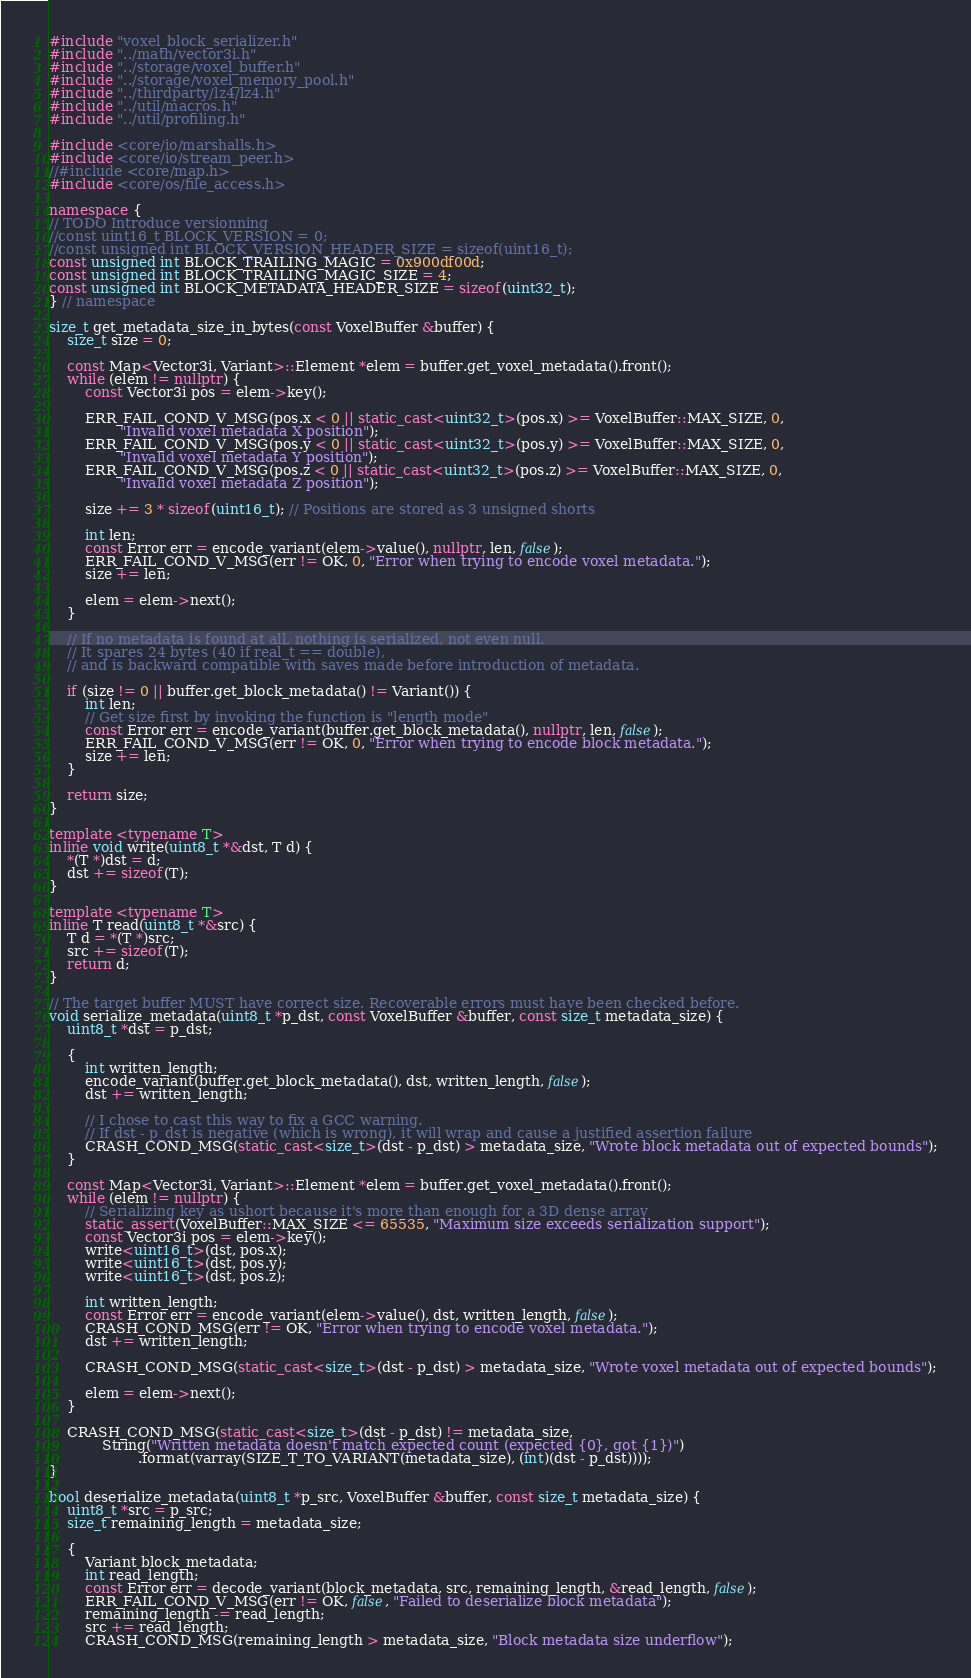<code> <loc_0><loc_0><loc_500><loc_500><_C++_>#include "voxel_block_serializer.h"
#include "../math/vector3i.h"
#include "../storage/voxel_buffer.h"
#include "../storage/voxel_memory_pool.h"
#include "../thirdparty/lz4/lz4.h"
#include "../util/macros.h"
#include "../util/profiling.h"

#include <core/io/marshalls.h>
#include <core/io/stream_peer.h>
//#include <core/map.h>
#include <core/os/file_access.h>

namespace {
// TODO Introduce versionning
//const uint16_t BLOCK_VERSION = 0;
//const unsigned int BLOCK_VERSION_HEADER_SIZE = sizeof(uint16_t);
const unsigned int BLOCK_TRAILING_MAGIC = 0x900df00d;
const unsigned int BLOCK_TRAILING_MAGIC_SIZE = 4;
const unsigned int BLOCK_METADATA_HEADER_SIZE = sizeof(uint32_t);
} // namespace

size_t get_metadata_size_in_bytes(const VoxelBuffer &buffer) {
	size_t size = 0;

	const Map<Vector3i, Variant>::Element *elem = buffer.get_voxel_metadata().front();
	while (elem != nullptr) {
		const Vector3i pos = elem->key();

		ERR_FAIL_COND_V_MSG(pos.x < 0 || static_cast<uint32_t>(pos.x) >= VoxelBuffer::MAX_SIZE, 0,
				"Invalid voxel metadata X position");
		ERR_FAIL_COND_V_MSG(pos.y < 0 || static_cast<uint32_t>(pos.y) >= VoxelBuffer::MAX_SIZE, 0,
				"Invalid voxel metadata Y position");
		ERR_FAIL_COND_V_MSG(pos.z < 0 || static_cast<uint32_t>(pos.z) >= VoxelBuffer::MAX_SIZE, 0,
				"Invalid voxel metadata Z position");

		size += 3 * sizeof(uint16_t); // Positions are stored as 3 unsigned shorts

		int len;
		const Error err = encode_variant(elem->value(), nullptr, len, false);
		ERR_FAIL_COND_V_MSG(err != OK, 0, "Error when trying to encode voxel metadata.");
		size += len;

		elem = elem->next();
	}

	// If no metadata is found at all, nothing is serialized, not even null.
	// It spares 24 bytes (40 if real_t == double),
	// and is backward compatible with saves made before introduction of metadata.

	if (size != 0 || buffer.get_block_metadata() != Variant()) {
		int len;
		// Get size first by invoking the function is "length mode"
		const Error err = encode_variant(buffer.get_block_metadata(), nullptr, len, false);
		ERR_FAIL_COND_V_MSG(err != OK, 0, "Error when trying to encode block metadata.");
		size += len;
	}

	return size;
}

template <typename T>
inline void write(uint8_t *&dst, T d) {
	*(T *)dst = d;
	dst += sizeof(T);
}

template <typename T>
inline T read(uint8_t *&src) {
	T d = *(T *)src;
	src += sizeof(T);
	return d;
}

// The target buffer MUST have correct size. Recoverable errors must have been checked before.
void serialize_metadata(uint8_t *p_dst, const VoxelBuffer &buffer, const size_t metadata_size) {
	uint8_t *dst = p_dst;

	{
		int written_length;
		encode_variant(buffer.get_block_metadata(), dst, written_length, false);
		dst += written_length;

		// I chose to cast this way to fix a GCC warning.
		// If dst - p_dst is negative (which is wrong), it will wrap and cause a justified assertion failure
		CRASH_COND_MSG(static_cast<size_t>(dst - p_dst) > metadata_size, "Wrote block metadata out of expected bounds");
	}

	const Map<Vector3i, Variant>::Element *elem = buffer.get_voxel_metadata().front();
	while (elem != nullptr) {
		// Serializing key as ushort because it's more than enough for a 3D dense array
		static_assert(VoxelBuffer::MAX_SIZE <= 65535, "Maximum size exceeds serialization support");
		const Vector3i pos = elem->key();
		write<uint16_t>(dst, pos.x);
		write<uint16_t>(dst, pos.y);
		write<uint16_t>(dst, pos.z);

		int written_length;
		const Error err = encode_variant(elem->value(), dst, written_length, false);
		CRASH_COND_MSG(err != OK, "Error when trying to encode voxel metadata.");
		dst += written_length;

		CRASH_COND_MSG(static_cast<size_t>(dst - p_dst) > metadata_size, "Wrote voxel metadata out of expected bounds");

		elem = elem->next();
	}

	CRASH_COND_MSG(static_cast<size_t>(dst - p_dst) != metadata_size,
			String("Written metadata doesn't match expected count (expected {0}, got {1})")
					.format(varray(SIZE_T_TO_VARIANT(metadata_size), (int)(dst - p_dst))));
}

bool deserialize_metadata(uint8_t *p_src, VoxelBuffer &buffer, const size_t metadata_size) {
	uint8_t *src = p_src;
	size_t remaining_length = metadata_size;

	{
		Variant block_metadata;
		int read_length;
		const Error err = decode_variant(block_metadata, src, remaining_length, &read_length, false);
		ERR_FAIL_COND_V_MSG(err != OK, false, "Failed to deserialize block metadata");
		remaining_length -= read_length;
		src += read_length;
		CRASH_COND_MSG(remaining_length > metadata_size, "Block metadata size underflow");</code> 